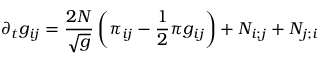Convert formula to latex. <formula><loc_0><loc_0><loc_500><loc_500>\partial _ { t } g _ { i j } = { \frac { 2 N } { \sqrt { g } } } \left ( \pi _ { i j } - { \frac { 1 } { 2 } } \pi g _ { i j } \right ) + N _ { i ; j } + N _ { j ; i }</formula> 